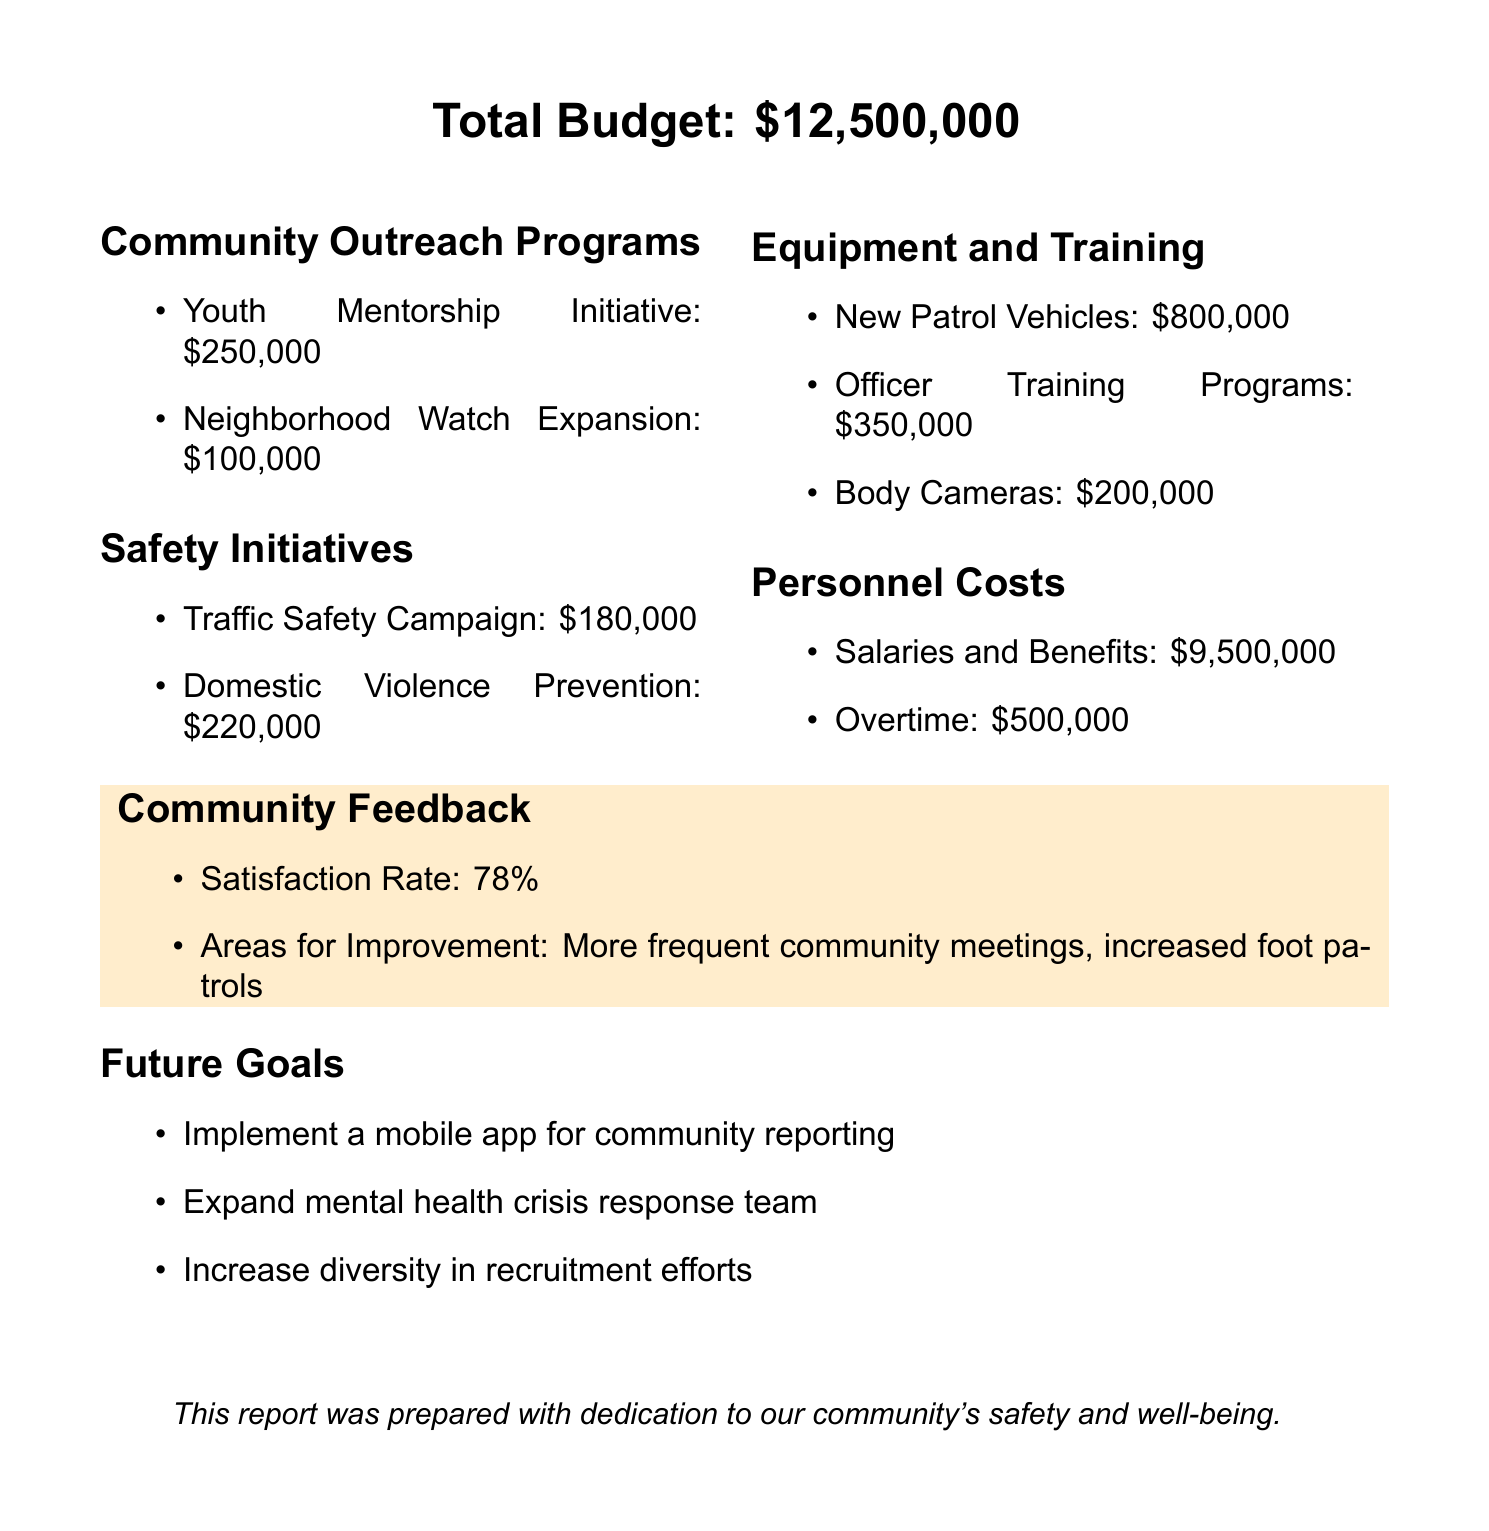What is the total budget for the fiscal year? The total budget is stated at the beginning of the report under total budget.
Answer: $12,500,000 How much is allocated to the Youth Mentorship Initiative? The amount for this specific community outreach program is listed in the community outreach programs section.
Answer: $250,000 What is the budget for the Domestic Violence Prevention initiative? The amount is found under safety initiatives, listed as part of their budget.
Answer: $220,000 What percentage of community satisfaction was reported? The satisfaction rate is provided in the community feedback section of the document.
Answer: 78% How much is budgeted for new patrol vehicles? This number can be found under equipment and training as part of their expenditures.
Answer: $800,000 What is one area for improvement noted in the community feedback? The areas listed for improvement can be found in the community feedback section.
Answer: More frequent community meetings How many safety initiatives are listed in the report? The number of safety initiatives can be counted from the section detailing them.
Answer: 2 What is one future goal mentioned in the report? Future goals listed can be found at the end of the document under the future goals section.
Answer: Implement a mobile app for community reporting What category has the highest expenditure according to personnel costs? By reviewing the personnel costs section, the item with the highest amount is identified.
Answer: Salaries and Benefits 